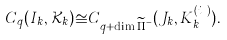Convert formula to latex. <formula><loc_0><loc_0><loc_500><loc_500>C _ { q } ( I _ { k } , \mathcal { K } _ { k } ) \cong C _ { q + \dim \widetilde { \Pi } ^ { - } _ { k } } ( J _ { k } , K ^ { ( i _ { k } ) } _ { k } ) .</formula> 